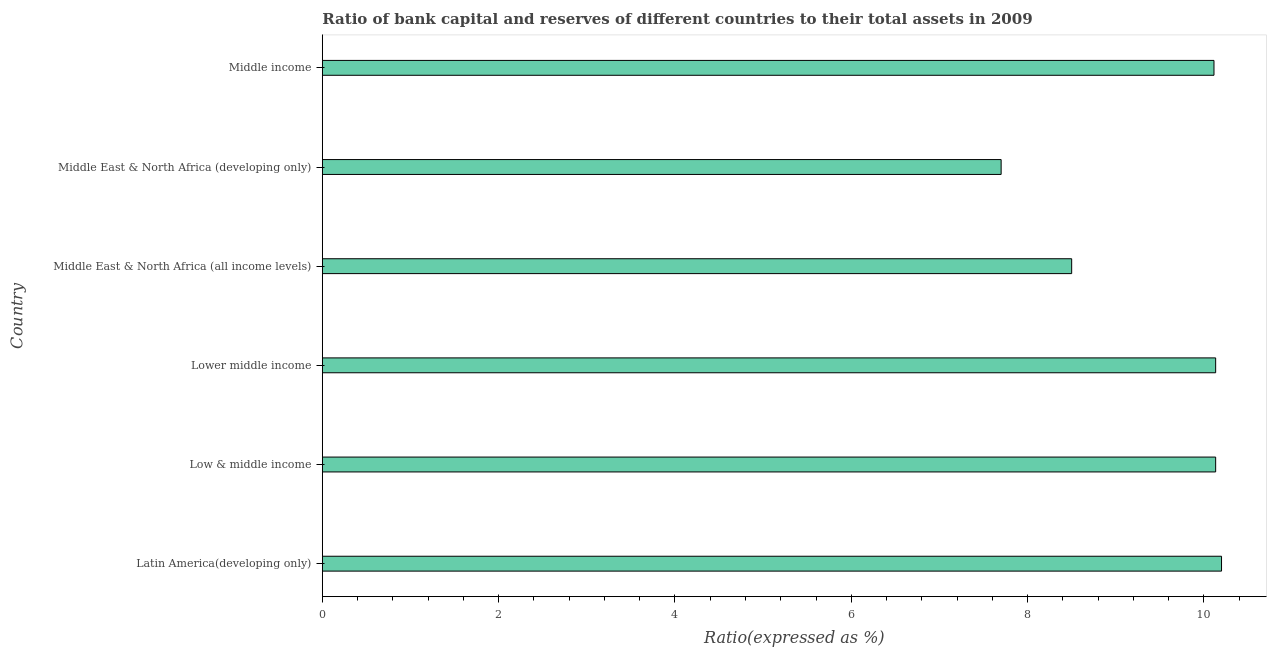Does the graph contain any zero values?
Offer a terse response. No. What is the title of the graph?
Offer a terse response. Ratio of bank capital and reserves of different countries to their total assets in 2009. What is the label or title of the X-axis?
Offer a terse response. Ratio(expressed as %). In which country was the bank capital to assets ratio maximum?
Give a very brief answer. Latin America(developing only). In which country was the bank capital to assets ratio minimum?
Offer a terse response. Middle East & North Africa (developing only). What is the sum of the bank capital to assets ratio?
Provide a succinct answer. 56.78. What is the difference between the bank capital to assets ratio in Latin America(developing only) and Low & middle income?
Your answer should be very brief. 0.07. What is the average bank capital to assets ratio per country?
Your answer should be very brief. 9.46. What is the median bank capital to assets ratio?
Provide a short and direct response. 10.12. Is the bank capital to assets ratio in Middle East & North Africa (all income levels) less than that in Middle income?
Keep it short and to the point. Yes. Is the difference between the bank capital to assets ratio in Latin America(developing only) and Lower middle income greater than the difference between any two countries?
Your response must be concise. No. What is the difference between the highest and the second highest bank capital to assets ratio?
Provide a succinct answer. 0.07. Is the sum of the bank capital to assets ratio in Low & middle income and Middle East & North Africa (all income levels) greater than the maximum bank capital to assets ratio across all countries?
Your response must be concise. Yes. What is the difference between the highest and the lowest bank capital to assets ratio?
Make the answer very short. 2.5. In how many countries, is the bank capital to assets ratio greater than the average bank capital to assets ratio taken over all countries?
Your response must be concise. 4. How many bars are there?
Make the answer very short. 6. What is the difference between two consecutive major ticks on the X-axis?
Your answer should be very brief. 2. Are the values on the major ticks of X-axis written in scientific E-notation?
Provide a succinct answer. No. What is the Ratio(expressed as %) in Low & middle income?
Give a very brief answer. 10.13. What is the Ratio(expressed as %) in Lower middle income?
Keep it short and to the point. 10.13. What is the Ratio(expressed as %) of Middle East & North Africa (developing only)?
Make the answer very short. 7.7. What is the Ratio(expressed as %) in Middle income?
Offer a terse response. 10.11. What is the difference between the Ratio(expressed as %) in Latin America(developing only) and Low & middle income?
Your response must be concise. 0.07. What is the difference between the Ratio(expressed as %) in Latin America(developing only) and Lower middle income?
Offer a terse response. 0.07. What is the difference between the Ratio(expressed as %) in Latin America(developing only) and Middle East & North Africa (all income levels)?
Offer a very short reply. 1.7. What is the difference between the Ratio(expressed as %) in Latin America(developing only) and Middle East & North Africa (developing only)?
Provide a short and direct response. 2.5. What is the difference between the Ratio(expressed as %) in Latin America(developing only) and Middle income?
Offer a very short reply. 0.09. What is the difference between the Ratio(expressed as %) in Low & middle income and Lower middle income?
Keep it short and to the point. 0. What is the difference between the Ratio(expressed as %) in Low & middle income and Middle East & North Africa (all income levels)?
Your response must be concise. 1.63. What is the difference between the Ratio(expressed as %) in Low & middle income and Middle East & North Africa (developing only)?
Your answer should be compact. 2.43. What is the difference between the Ratio(expressed as %) in Low & middle income and Middle income?
Your answer should be compact. 0.02. What is the difference between the Ratio(expressed as %) in Lower middle income and Middle East & North Africa (all income levels)?
Your answer should be compact. 1.63. What is the difference between the Ratio(expressed as %) in Lower middle income and Middle East & North Africa (developing only)?
Give a very brief answer. 2.43. What is the difference between the Ratio(expressed as %) in Lower middle income and Middle income?
Offer a terse response. 0.02. What is the difference between the Ratio(expressed as %) in Middle East & North Africa (all income levels) and Middle East & North Africa (developing only)?
Provide a short and direct response. 0.8. What is the difference between the Ratio(expressed as %) in Middle East & North Africa (all income levels) and Middle income?
Your answer should be very brief. -1.61. What is the difference between the Ratio(expressed as %) in Middle East & North Africa (developing only) and Middle income?
Give a very brief answer. -2.41. What is the ratio of the Ratio(expressed as %) in Latin America(developing only) to that in Low & middle income?
Offer a terse response. 1.01. What is the ratio of the Ratio(expressed as %) in Latin America(developing only) to that in Middle East & North Africa (all income levels)?
Your answer should be compact. 1.2. What is the ratio of the Ratio(expressed as %) in Latin America(developing only) to that in Middle East & North Africa (developing only)?
Give a very brief answer. 1.32. What is the ratio of the Ratio(expressed as %) in Latin America(developing only) to that in Middle income?
Your answer should be very brief. 1.01. What is the ratio of the Ratio(expressed as %) in Low & middle income to that in Lower middle income?
Your response must be concise. 1. What is the ratio of the Ratio(expressed as %) in Low & middle income to that in Middle East & North Africa (all income levels)?
Ensure brevity in your answer.  1.19. What is the ratio of the Ratio(expressed as %) in Low & middle income to that in Middle East & North Africa (developing only)?
Ensure brevity in your answer.  1.32. What is the ratio of the Ratio(expressed as %) in Lower middle income to that in Middle East & North Africa (all income levels)?
Your answer should be very brief. 1.19. What is the ratio of the Ratio(expressed as %) in Lower middle income to that in Middle East & North Africa (developing only)?
Your response must be concise. 1.32. What is the ratio of the Ratio(expressed as %) in Middle East & North Africa (all income levels) to that in Middle East & North Africa (developing only)?
Provide a succinct answer. 1.1. What is the ratio of the Ratio(expressed as %) in Middle East & North Africa (all income levels) to that in Middle income?
Offer a very short reply. 0.84. What is the ratio of the Ratio(expressed as %) in Middle East & North Africa (developing only) to that in Middle income?
Keep it short and to the point. 0.76. 